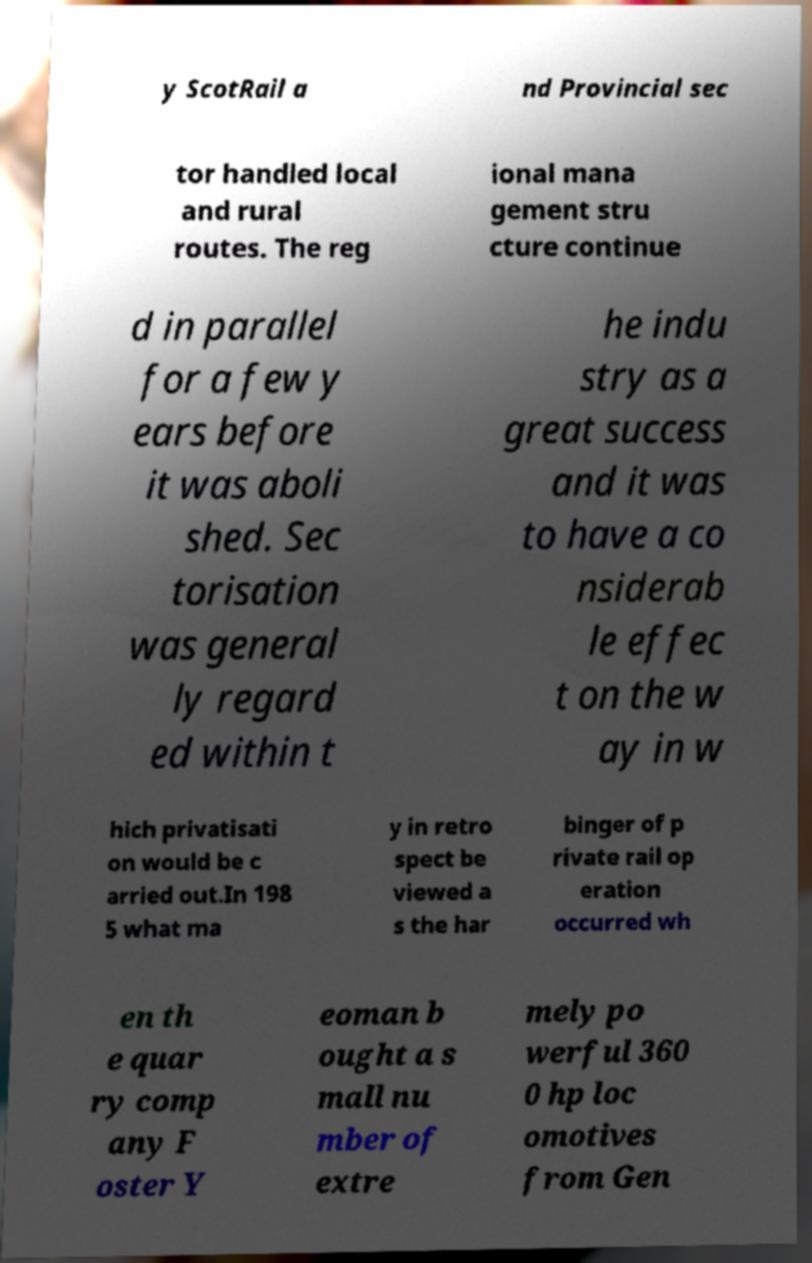Can you read and provide the text displayed in the image?This photo seems to have some interesting text. Can you extract and type it out for me? y ScotRail a nd Provincial sec tor handled local and rural routes. The reg ional mana gement stru cture continue d in parallel for a few y ears before it was aboli shed. Sec torisation was general ly regard ed within t he indu stry as a great success and it was to have a co nsiderab le effec t on the w ay in w hich privatisati on would be c arried out.In 198 5 what ma y in retro spect be viewed a s the har binger of p rivate rail op eration occurred wh en th e quar ry comp any F oster Y eoman b ought a s mall nu mber of extre mely po werful 360 0 hp loc omotives from Gen 